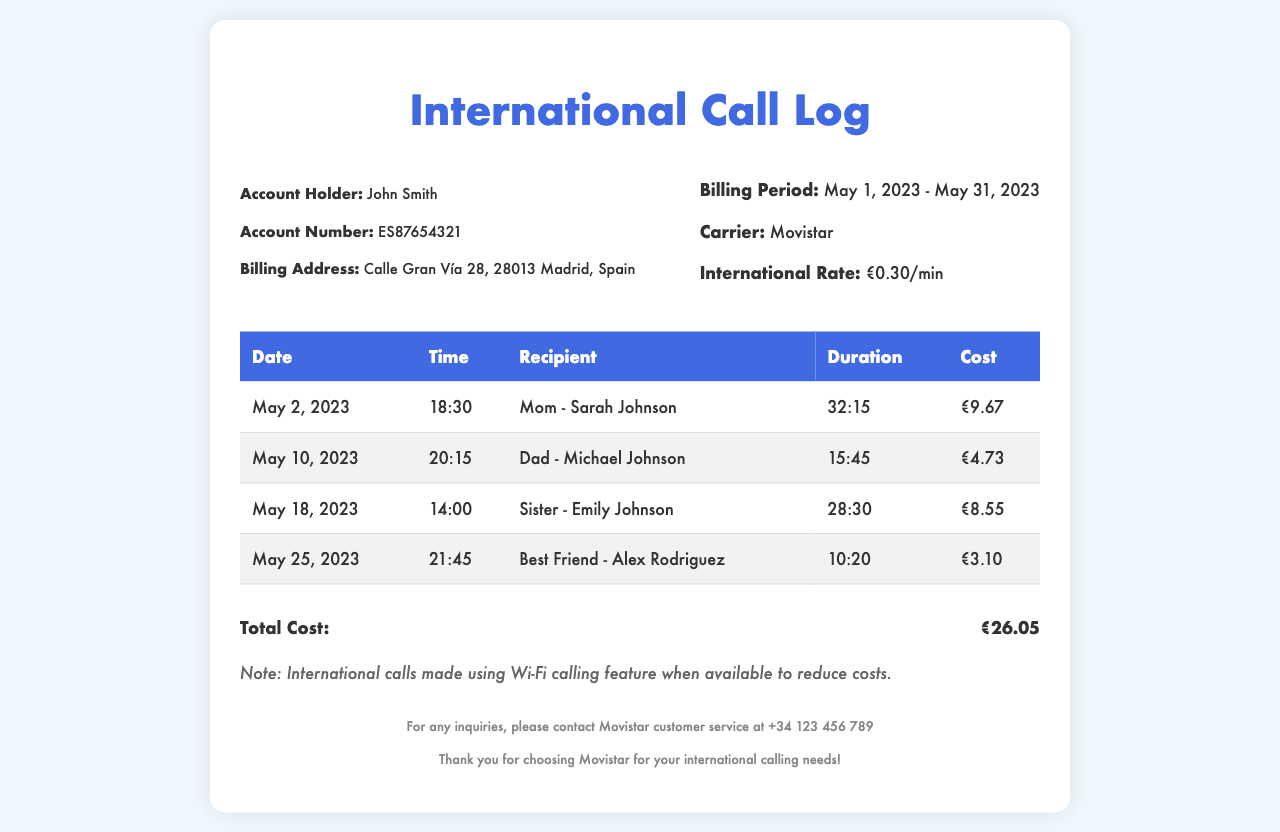What is the account holder's name? The account holder's name is mentioned in the document as John Smith.
Answer: John Smith What is the international rate per minute? The document specifies that the international rate is €0.30/min.
Answer: €0.30/min How long was the call to Mom on May 2, 2023? The duration of the call to Mom is stated as 32:15.
Answer: 32:15 What is the total cost of all international calls? The total cost is given as a summary at the end of the table, which is €26.05.
Answer: €26.05 Which recipient had the shortest call duration? The shortest call duration can be found by comparing the listed durations, which shows Best Friend - Alex Rodriguez had 10:20.
Answer: Best Friend - Alex Rodriguez What day did John Smith call his sister? The date of the call to his sister is noted as May 18, 2023.
Answer: May 18, 2023 What time was the call made to Dad? The time of the call to Dad is listed as 20:15.
Answer: 20:15 How many calls were made during the billing period? The document records a total of four calls as listed in the table.
Answer: Four What notes are provided in the document? The notes mention the use of Wi-Fi calling to reduce costs, as noted in the document.
Answer: International calls made using Wi-Fi calling feature when available to reduce costs 